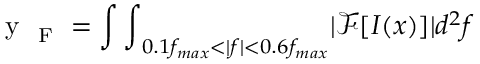<formula> <loc_0><loc_0><loc_500><loc_500>y _ { F } = { \int \int } _ { 0 . 1 f _ { \max } < | f | < 0 . 6 f _ { \max } } | \mathcal { F } [ I ( x ) ] | d ^ { 2 } f</formula> 